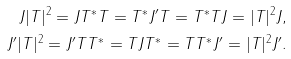Convert formula to latex. <formula><loc_0><loc_0><loc_500><loc_500>J | T | ^ { 2 } = J T ^ { * } T = T ^ { * } J ^ { \prime } T = T ^ { * } T J = | T | ^ { 2 } J , \\ J ^ { \prime } | T | ^ { 2 } = J ^ { \prime } T T ^ { * } = T J T ^ { * } = T T ^ { * } J ^ { \prime } = | T | ^ { 2 } J ^ { \prime } .</formula> 